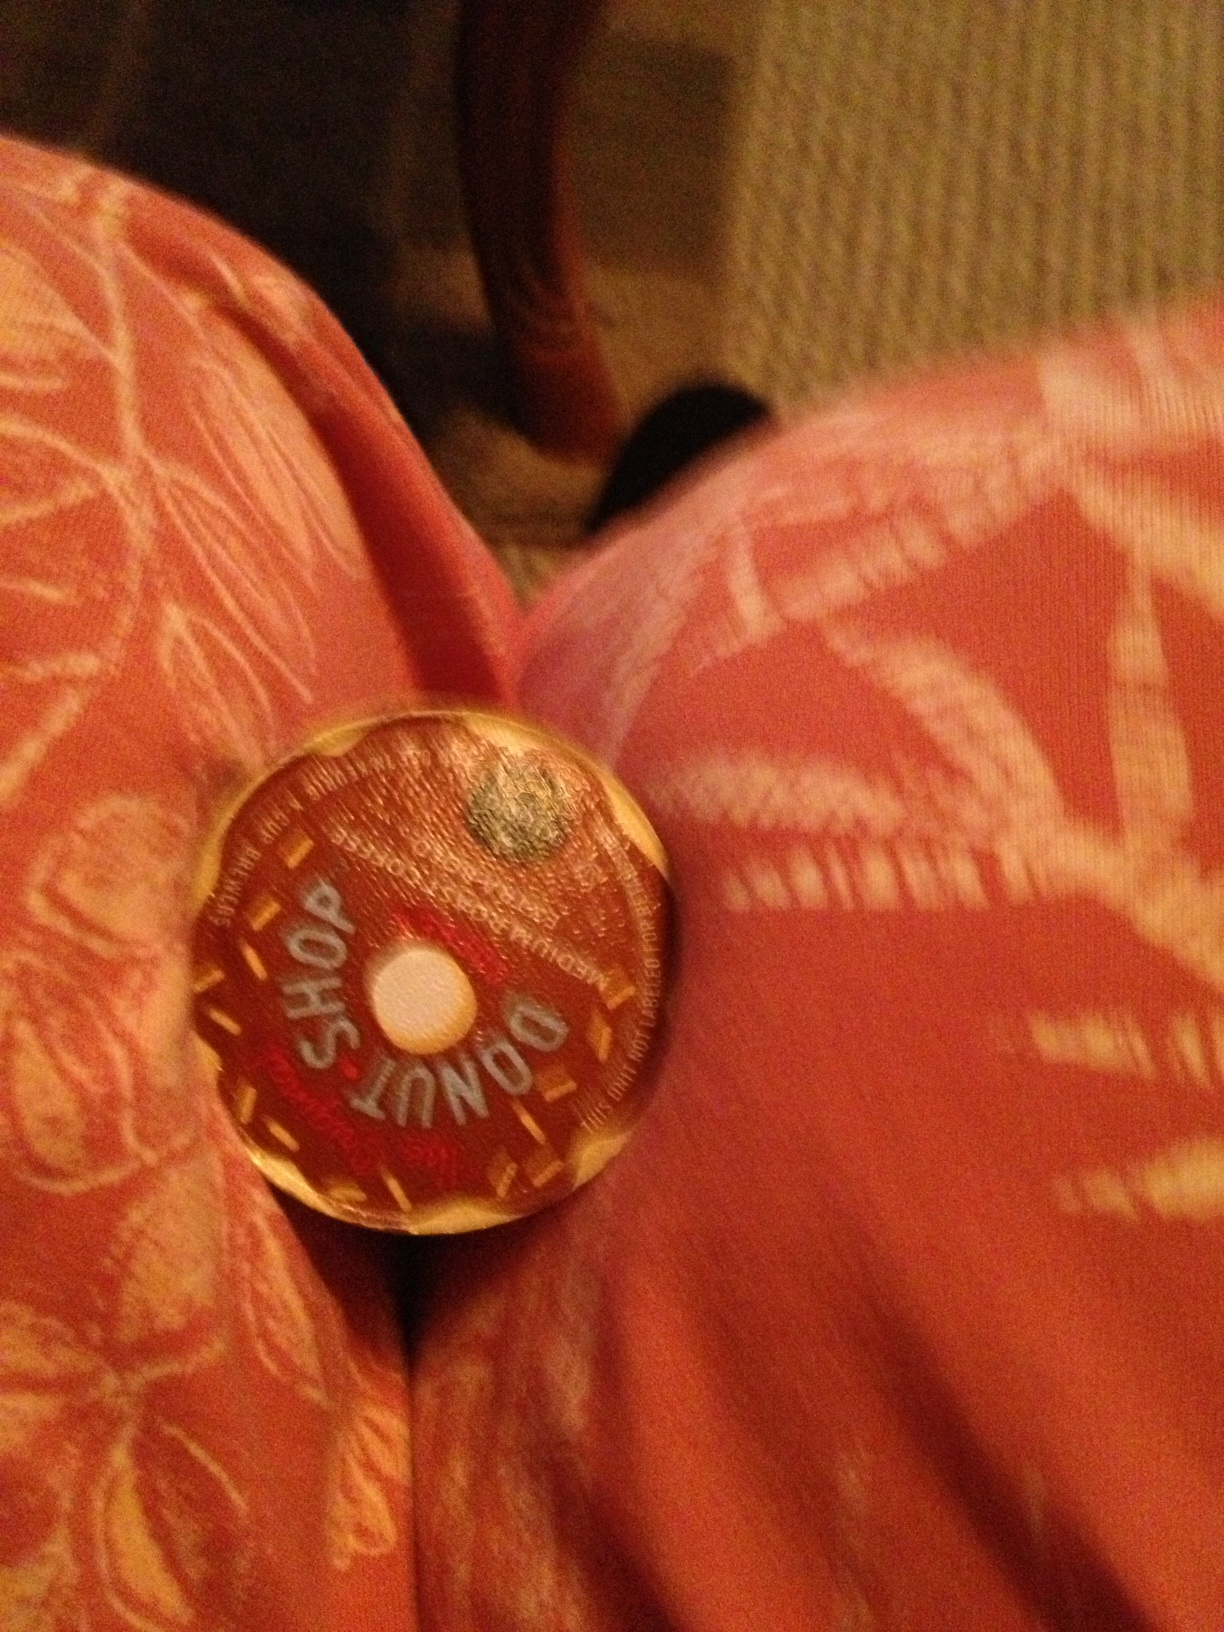How is this coffee usually prepared? This type of coffee is usually prepared using a single-serve coffee maker, commonly known as a Keurig machine. You simply insert the pod, select your desired cup size, and the machine does the rest, providing a quick and convenient way to enjoy a fresh cup of coffee. 